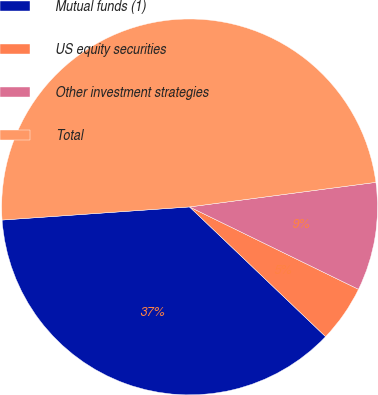<chart> <loc_0><loc_0><loc_500><loc_500><pie_chart><fcel>Mutual funds (1)<fcel>US equity securities<fcel>Other investment strategies<fcel>Total<nl><fcel>36.76%<fcel>4.9%<fcel>9.31%<fcel>49.02%<nl></chart> 